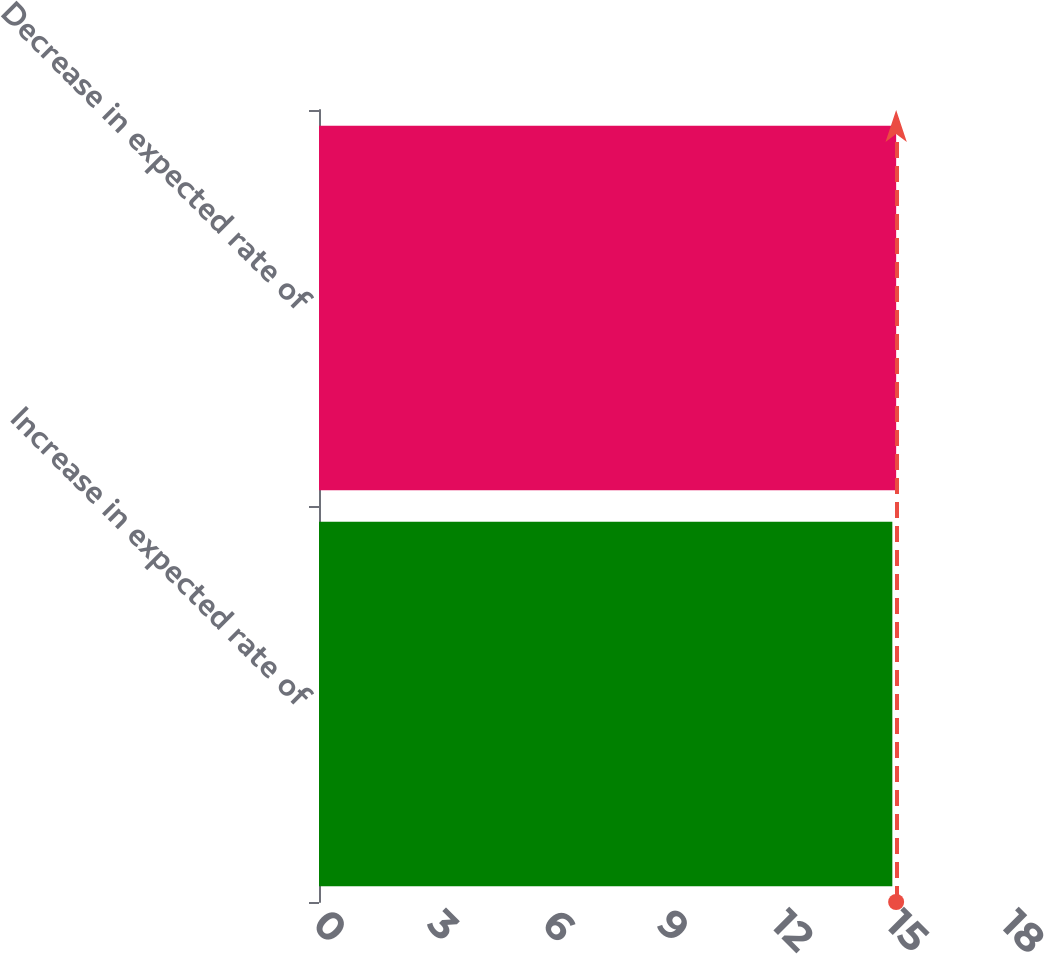Convert chart. <chart><loc_0><loc_0><loc_500><loc_500><bar_chart><fcel>Increase in expected rate of<fcel>Decrease in expected rate of<nl><fcel>15<fcel>15.1<nl></chart> 